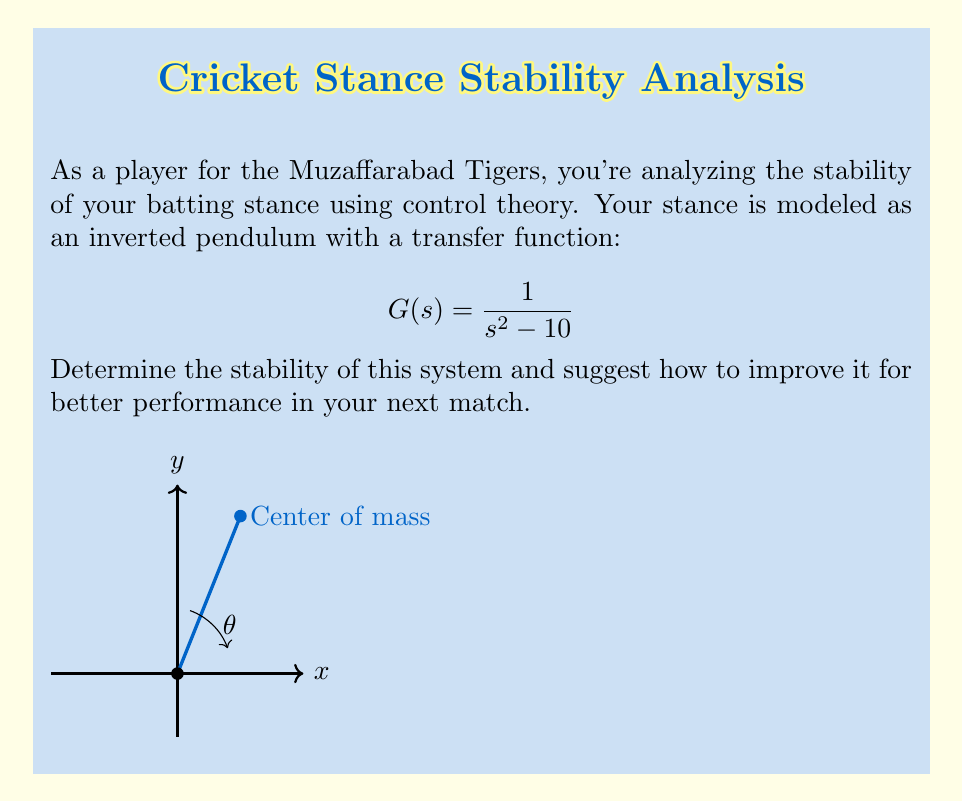Solve this math problem. To analyze the stability of the cricket player's batting stance modeled as an inverted pendulum, we'll follow these steps:

1) The characteristic equation of the system is obtained by setting the denominator of the transfer function to zero:

   $$s^2 - 10 = 0$$

2) Solve for the roots of this equation:

   $$s = \pm\sqrt{10} = \pm 3.16$$

3) For a system to be stable, all roots (poles) must have negative real parts. In this case, we have two real roots: one positive and one negative.

4) The positive root (3.16) indicates that the system is unstable. This means that any small disturbance will cause the player's stance to deviate further from equilibrium over time.

5) To improve stability, we need to modify the system to ensure all poles are in the left half of the s-plane. This can be achieved by adding a feedback controller.

6) A simple proportional controller with gain K would modify the characteristic equation to:

   $$s^2 + K - 10 = 0$$

7) For stability, we need K > 10. For example, if K = 20, the new roots would be:

   $$s = \pm\sqrt{10 - 20} = \pm 2.236i$$

   These imaginary roots indicate a stable, oscillatory system.

8) In cricket terms, this means the player should increase their "stiffness" or resistance to movement, perhaps by widening their stance or lowering their center of gravity.
Answer: Unstable; add feedback control with K > 10 to stabilize. 